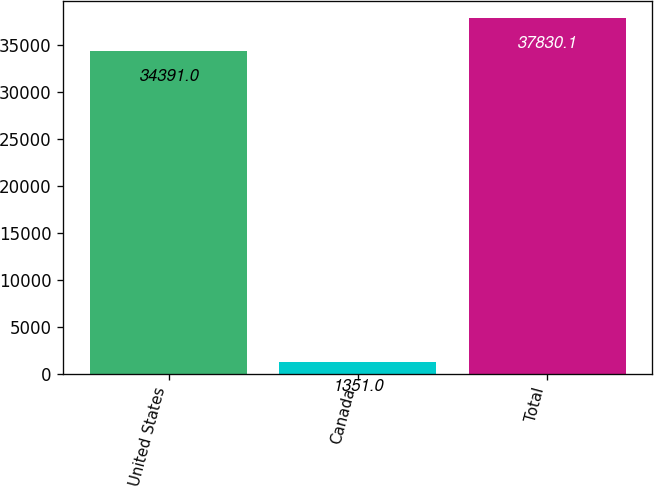Convert chart. <chart><loc_0><loc_0><loc_500><loc_500><bar_chart><fcel>United States<fcel>Canada<fcel>Total<nl><fcel>34391<fcel>1351<fcel>37830.1<nl></chart> 